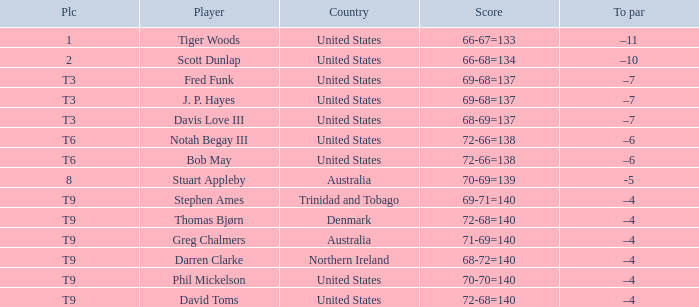What is the To par value that goes with a Score of 70-69=139? -5.0. 